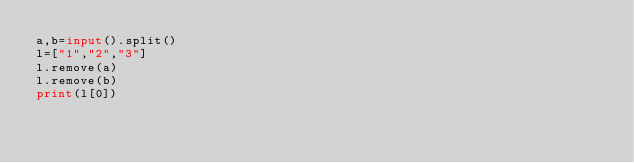Convert code to text. <code><loc_0><loc_0><loc_500><loc_500><_Python_>a,b=input().split()
l=["1","2","3"]
l.remove(a)
l.remove(b)
print(l[0])
</code> 